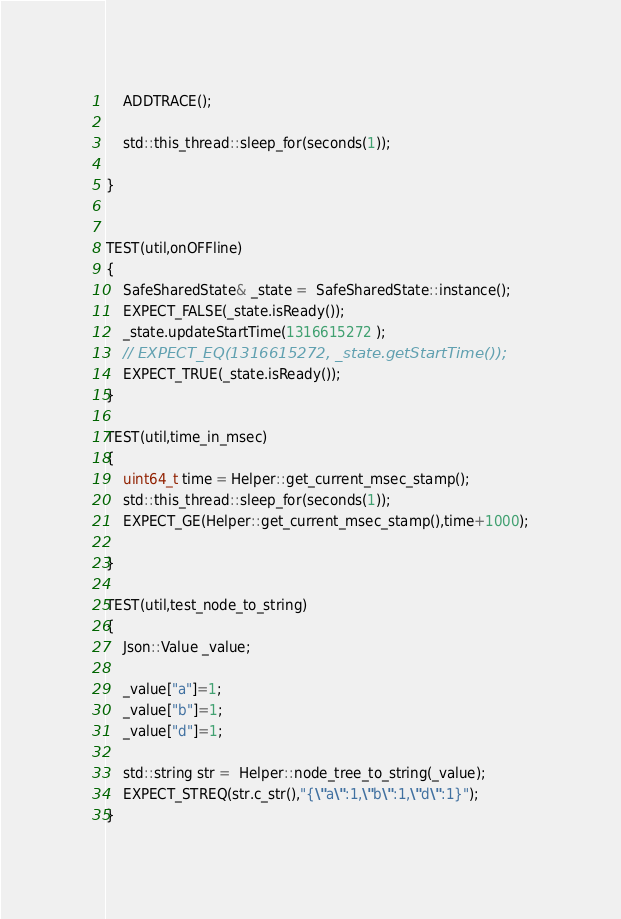Convert code to text. <code><loc_0><loc_0><loc_500><loc_500><_C++_>    ADDTRACE();

    std::this_thread::sleep_for(seconds(1));

}


TEST(util,onOFFline)
{
    SafeSharedState& _state =  SafeSharedState::instance();
    EXPECT_FALSE(_state.isReady());
    _state.updateStartTime(1316615272 );
    // EXPECT_EQ(1316615272, _state.getStartTime());
    EXPECT_TRUE(_state.isReady());
}

TEST(util,time_in_msec)
{
    uint64_t time = Helper::get_current_msec_stamp();
    std::this_thread::sleep_for(seconds(1));
    EXPECT_GE(Helper::get_current_msec_stamp(),time+1000);

}

TEST(util,test_node_to_string)
{
    Json::Value _value;

    _value["a"]=1;
    _value["b"]=1;
    _value["d"]=1;

    std::string str =  Helper::node_tree_to_string(_value);
    EXPECT_STREQ(str.c_str(),"{\"a\":1,\"b\":1,\"d\":1}");
}</code> 